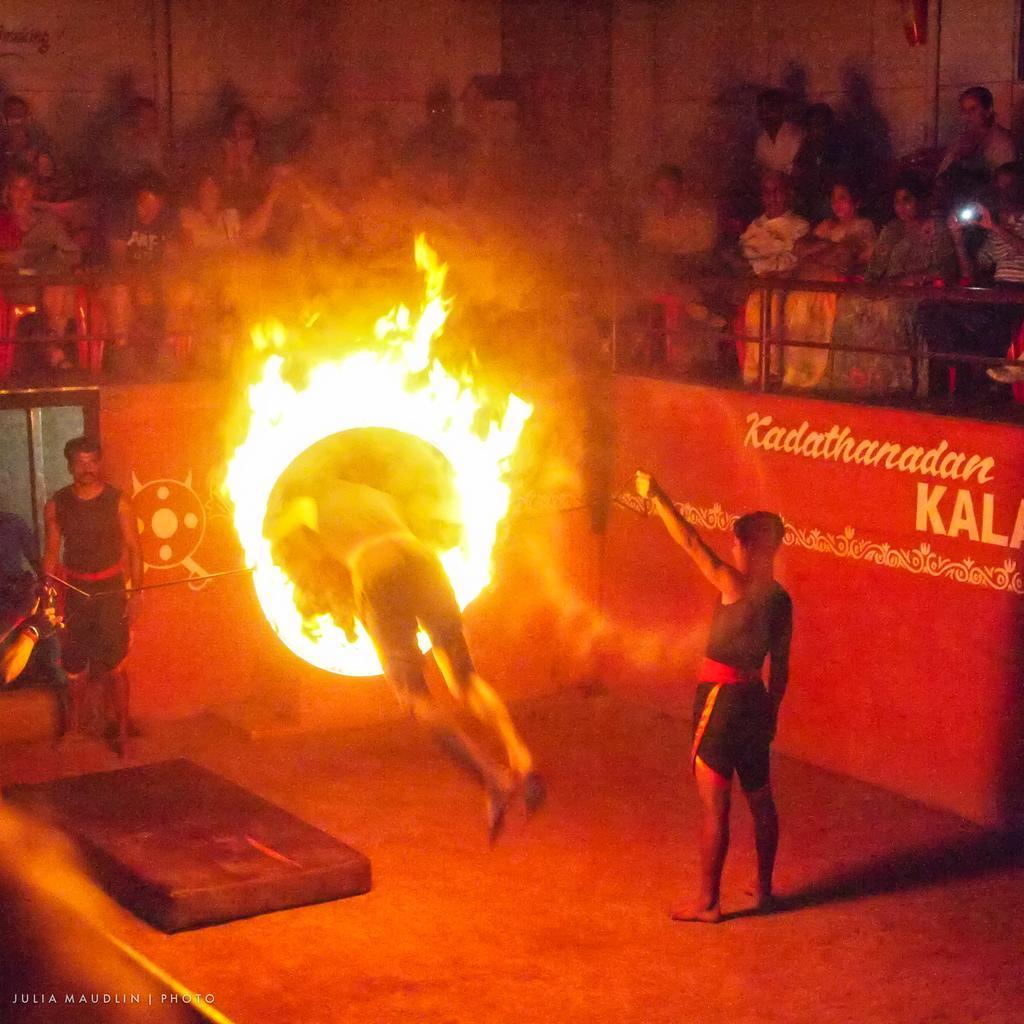Describe this image in one or two sentences. In this image I can see a man is jumping through a fire ring and two persons are standing in the front and back side of the man. I can see people sitting in chairs on the stage watching him. On the right hand side, I can see some text on a wall. The background is dark. 